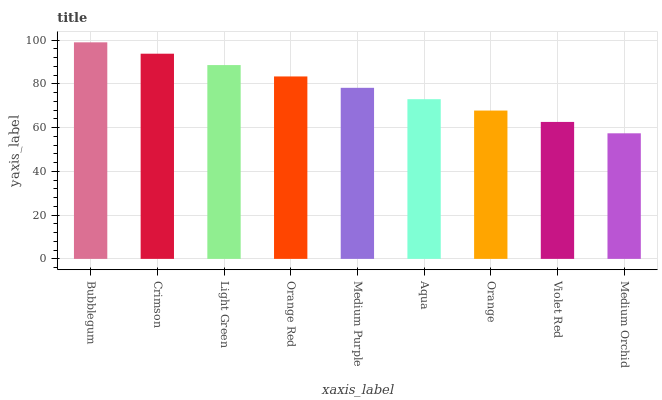Is Medium Orchid the minimum?
Answer yes or no. Yes. Is Bubblegum the maximum?
Answer yes or no. Yes. Is Crimson the minimum?
Answer yes or no. No. Is Crimson the maximum?
Answer yes or no. No. Is Bubblegum greater than Crimson?
Answer yes or no. Yes. Is Crimson less than Bubblegum?
Answer yes or no. Yes. Is Crimson greater than Bubblegum?
Answer yes or no. No. Is Bubblegum less than Crimson?
Answer yes or no. No. Is Medium Purple the high median?
Answer yes or no. Yes. Is Medium Purple the low median?
Answer yes or no. Yes. Is Orange the high median?
Answer yes or no. No. Is Orange the low median?
Answer yes or no. No. 